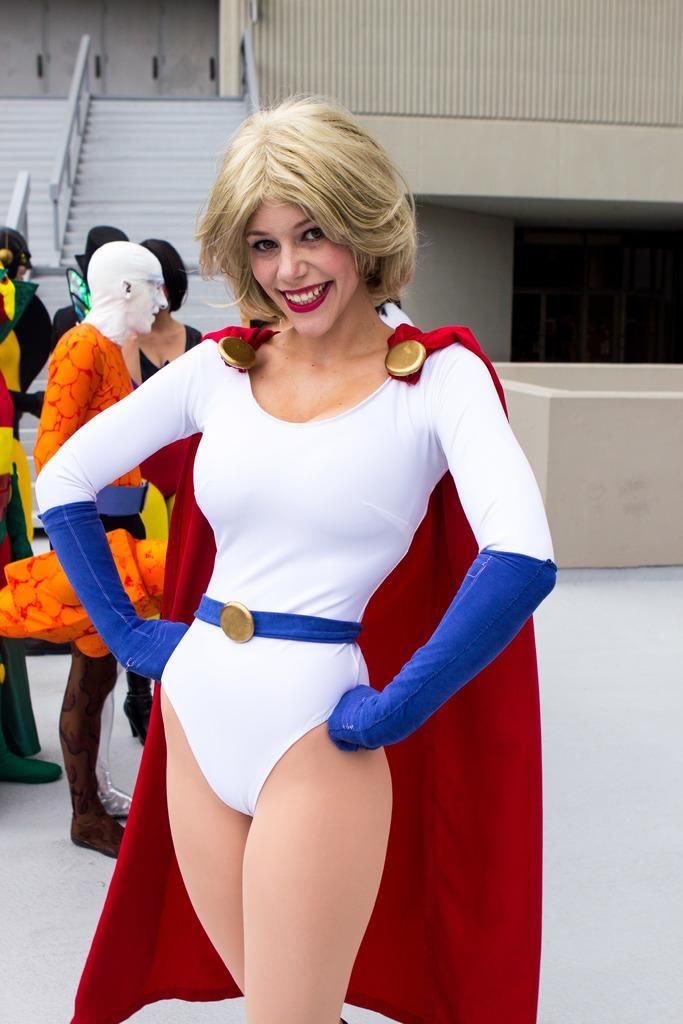Who is the main subject in the image? There is a lady in the center of the image. What is the lady doing in the image? The lady is standing and smiling. What is the lady wearing in the image? The lady is wearing a costume. What can be seen in the background of the image? There are people, stairs, and a wall in the background of the image. What is located on the right side of the image? There is a table on the right side of the image. What type of sand can be seen on the lady's costume in the image? There is no sand present on the lady's costume in the image. What is the lady's annual income in the image? There is no information about the lady's income in the image. 